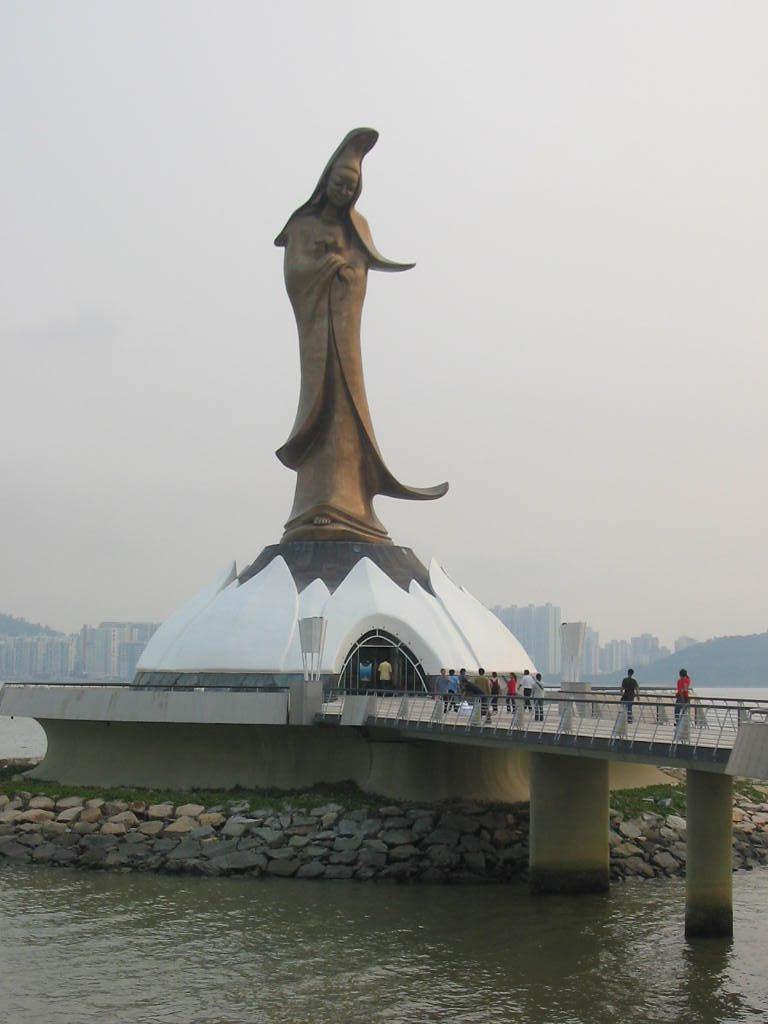In one or two sentences, can you explain what this image depicts? In this picture we can see water, few rocks and a statue, we can find few people on the bridge, in the background we can see few buildings. 